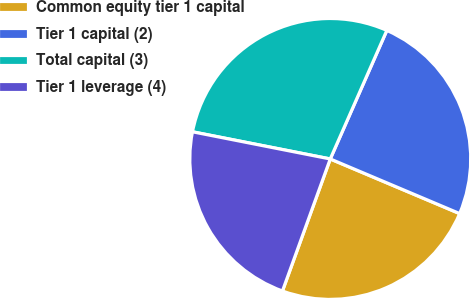Convert chart to OTSL. <chart><loc_0><loc_0><loc_500><loc_500><pie_chart><fcel>Common equity tier 1 capital<fcel>Tier 1 capital (2)<fcel>Total capital (3)<fcel>Tier 1 leverage (4)<nl><fcel>24.17%<fcel>24.76%<fcel>28.5%<fcel>22.57%<nl></chart> 